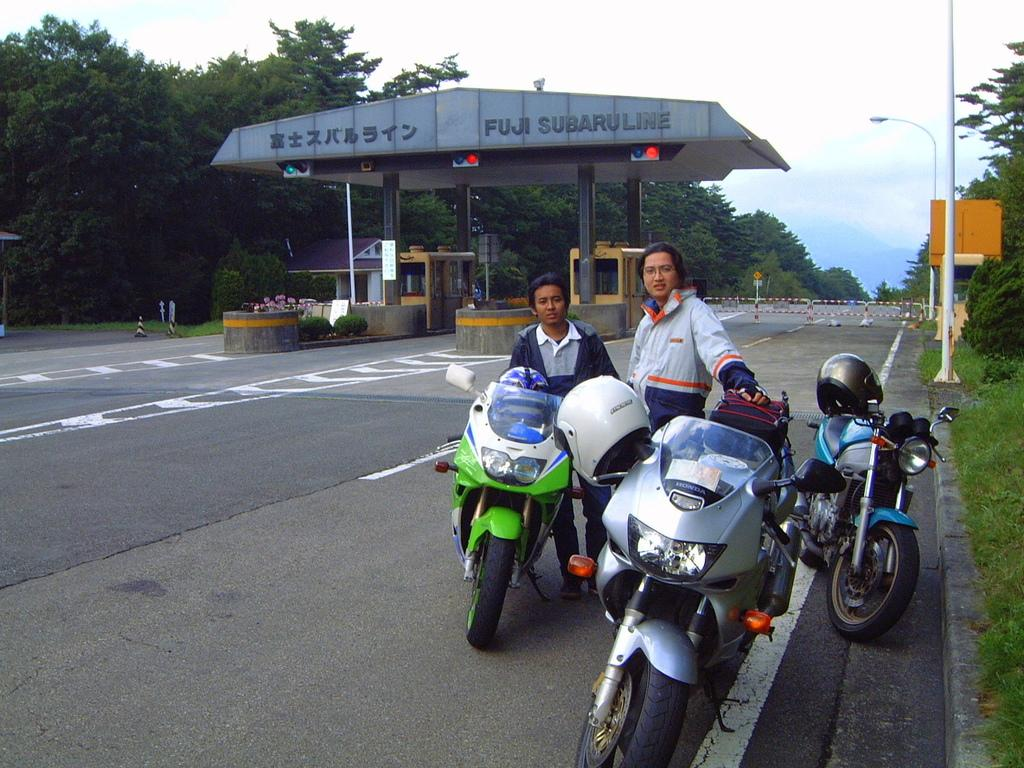What can be seen parked on the road in the image? There are bikes parked on the road in the image. What else is visible in the image besides the parked bikes? There are people standing in the image. What can be seen in the background of the image? There is an outer ring road toll gate visible in the background of the image. What type of flower is being sold at the toll gate in the image? A: There is no flower or indication of any flower being sold at the toll gate in the image. 